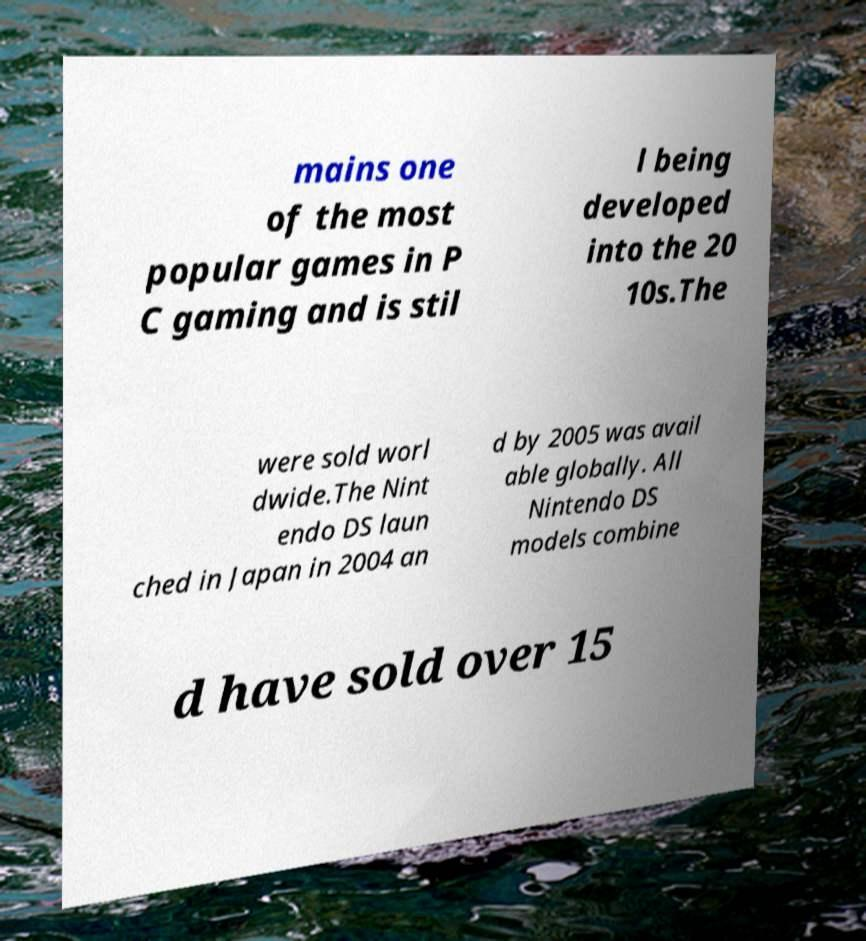For documentation purposes, I need the text within this image transcribed. Could you provide that? mains one of the most popular games in P C gaming and is stil l being developed into the 20 10s.The were sold worl dwide.The Nint endo DS laun ched in Japan in 2004 an d by 2005 was avail able globally. All Nintendo DS models combine d have sold over 15 